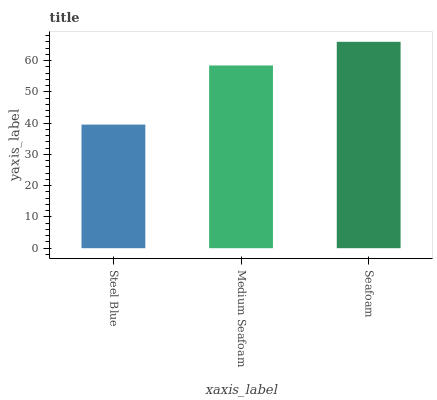Is Steel Blue the minimum?
Answer yes or no. Yes. Is Seafoam the maximum?
Answer yes or no. Yes. Is Medium Seafoam the minimum?
Answer yes or no. No. Is Medium Seafoam the maximum?
Answer yes or no. No. Is Medium Seafoam greater than Steel Blue?
Answer yes or no. Yes. Is Steel Blue less than Medium Seafoam?
Answer yes or no. Yes. Is Steel Blue greater than Medium Seafoam?
Answer yes or no. No. Is Medium Seafoam less than Steel Blue?
Answer yes or no. No. Is Medium Seafoam the high median?
Answer yes or no. Yes. Is Medium Seafoam the low median?
Answer yes or no. Yes. Is Seafoam the high median?
Answer yes or no. No. Is Steel Blue the low median?
Answer yes or no. No. 